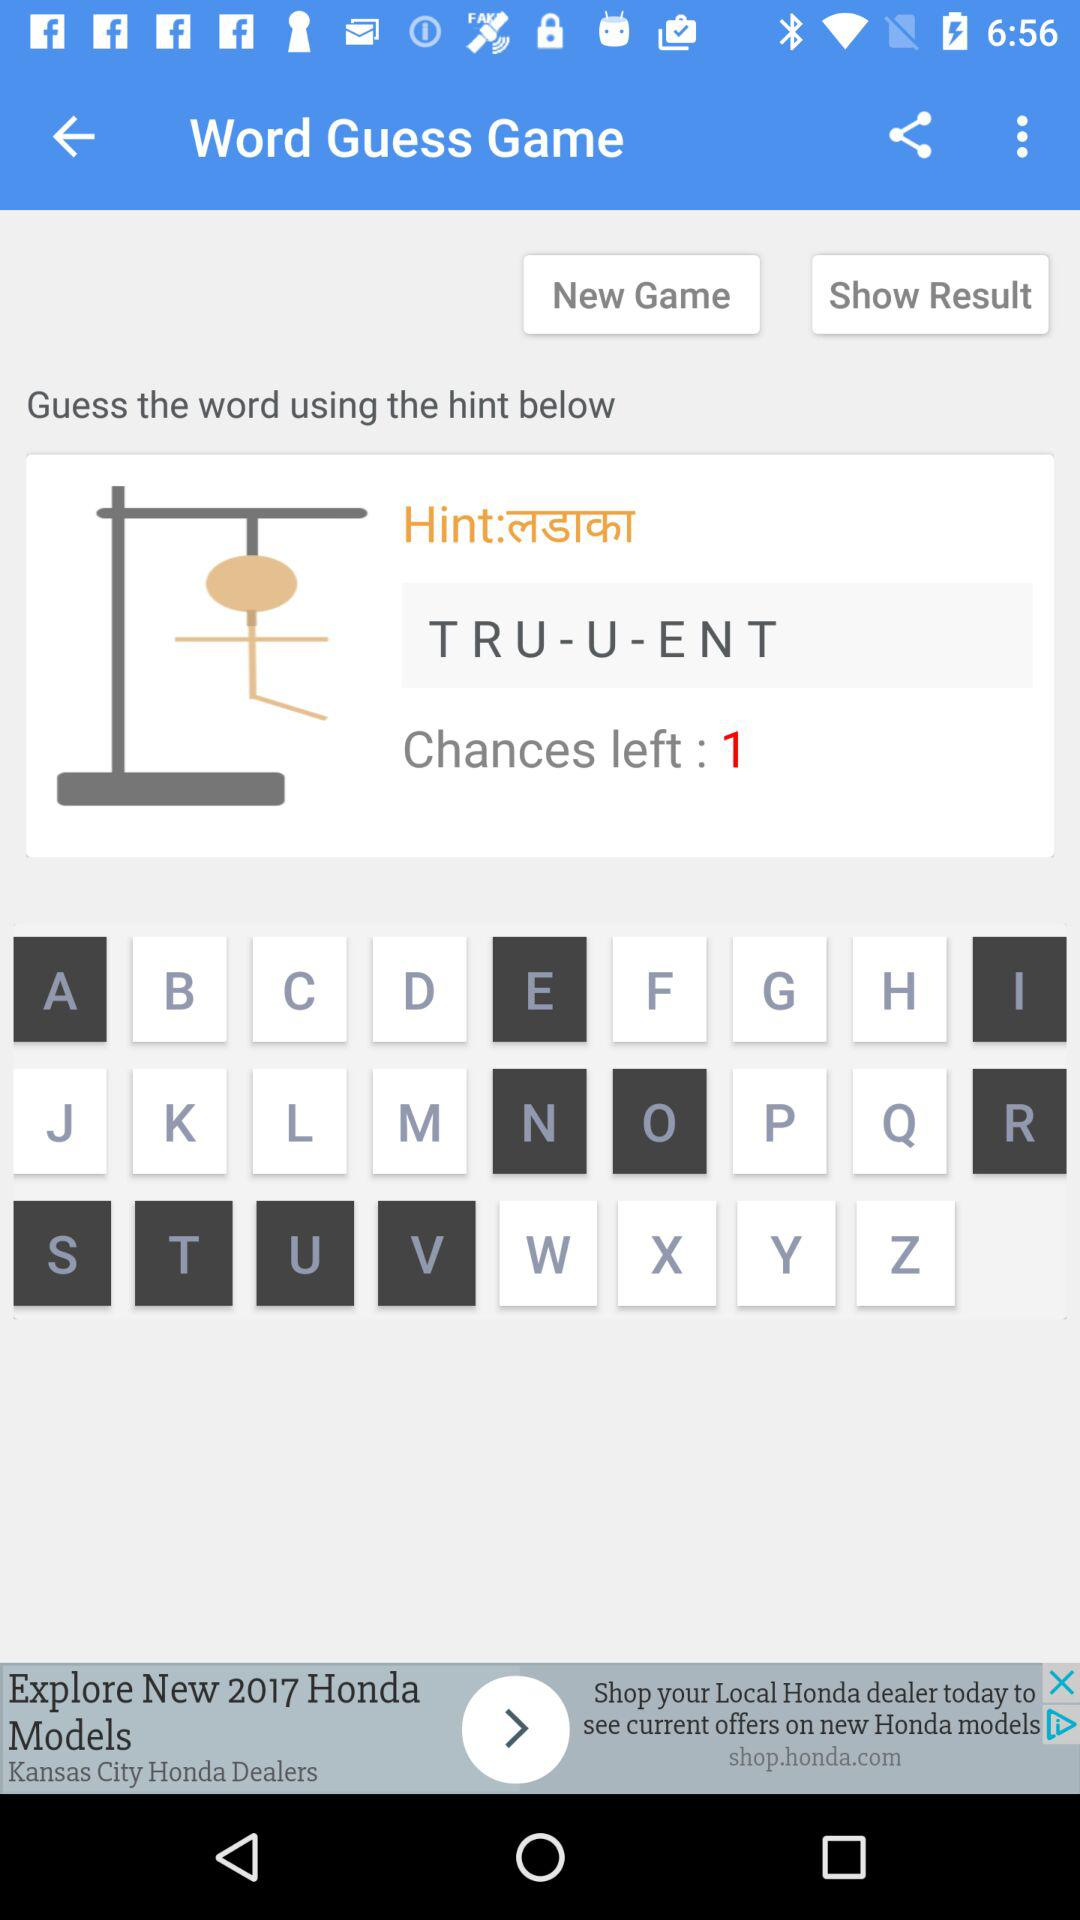What is the name of the game? The name of the game is "Word Guess Game". 